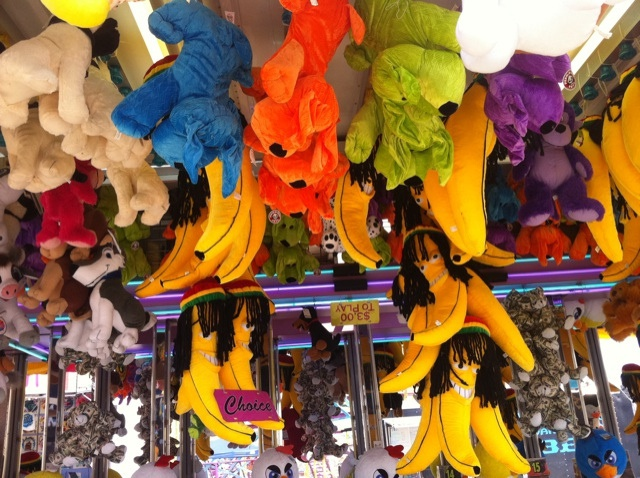Describe the objects in this image and their specific colors. I can see banana in maroon, orange, black, and gold tones, banana in maroon, orange, gold, black, and olive tones, banana in maroon, orange, brown, and gold tones, teddy bear in maroon, black, and purple tones, and banana in maroon, orange, gold, and olive tones in this image. 